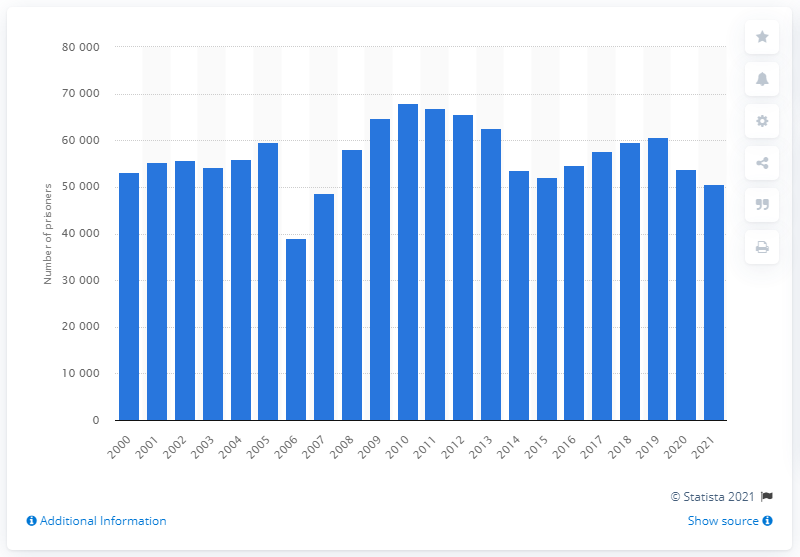Highlight a few significant elements in this photo. By the end of 2019, there were approximately 60,769 inmates in Italy. As of February 2021, there were approximately 50,551 prisoners in Italy. 